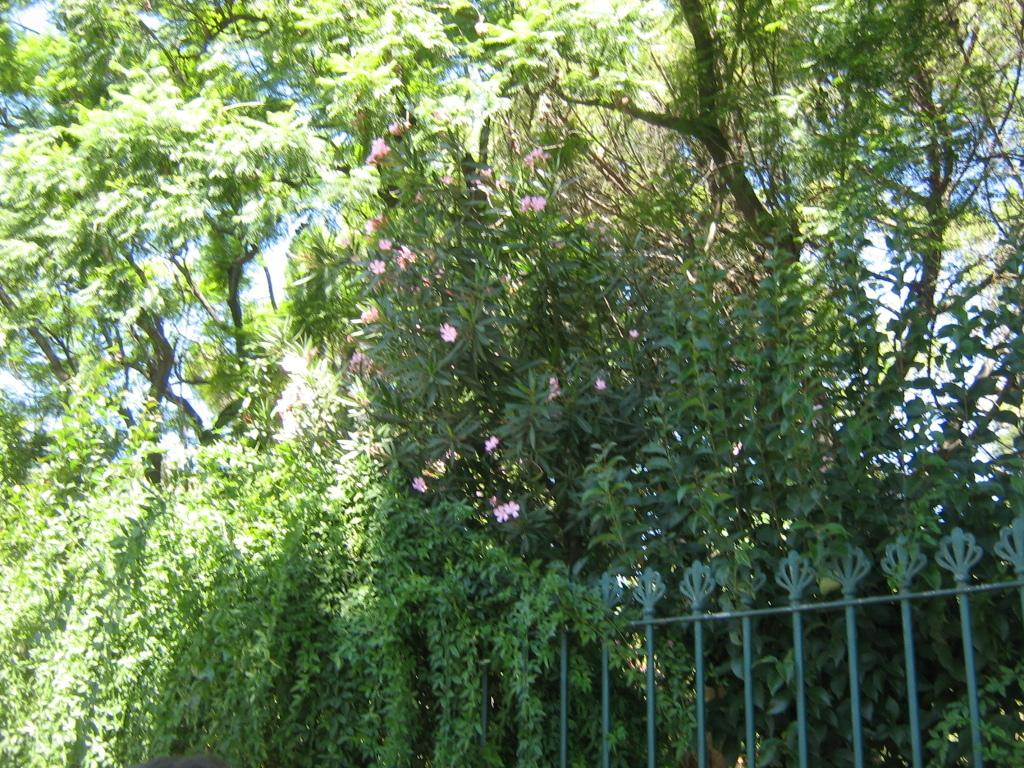What type of vegetation can be seen in the image? There are trees and plants with flowers in the image. What is the purpose of the fence in the image? The purpose of the fence in the image is not clear, but it could be for separating or enclosing areas. What is visible in the background of the image? The sky is visible in the image. What type of ornament is hanging from the tree in the image? There is no ornament hanging from the tree in the image; only trees, plants with flowers, a fence, and the sky are present. 